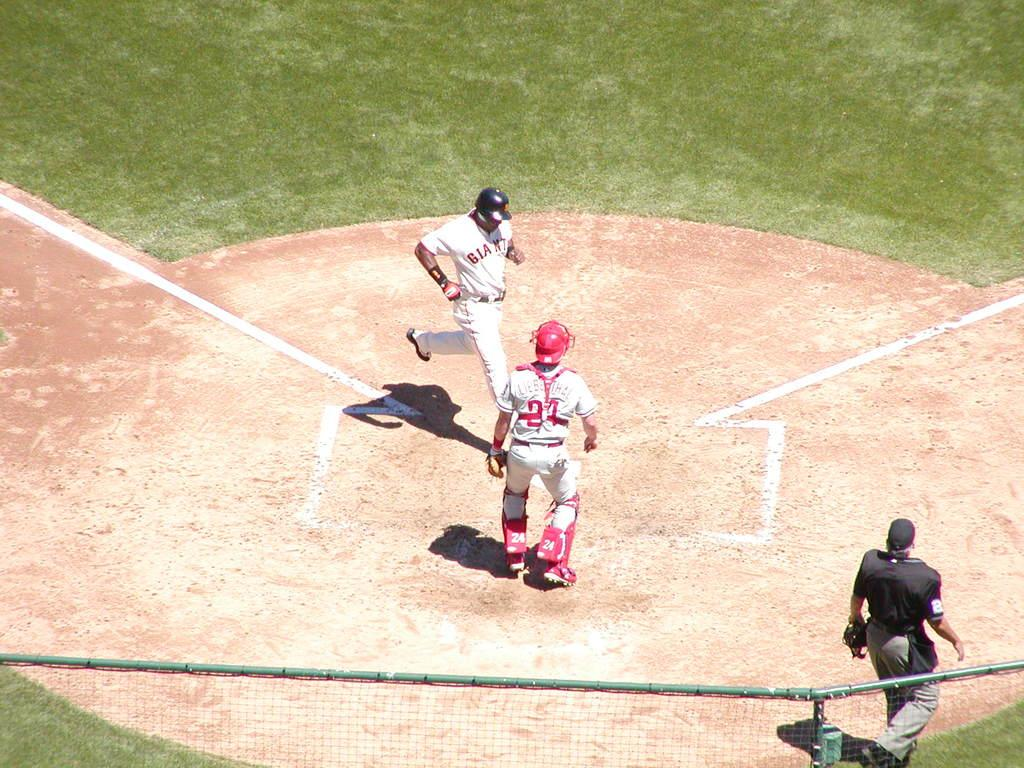Provide a one-sentence caption for the provided image. A Giants baseball player steps on home plate in front of the catcher and the umpire. 